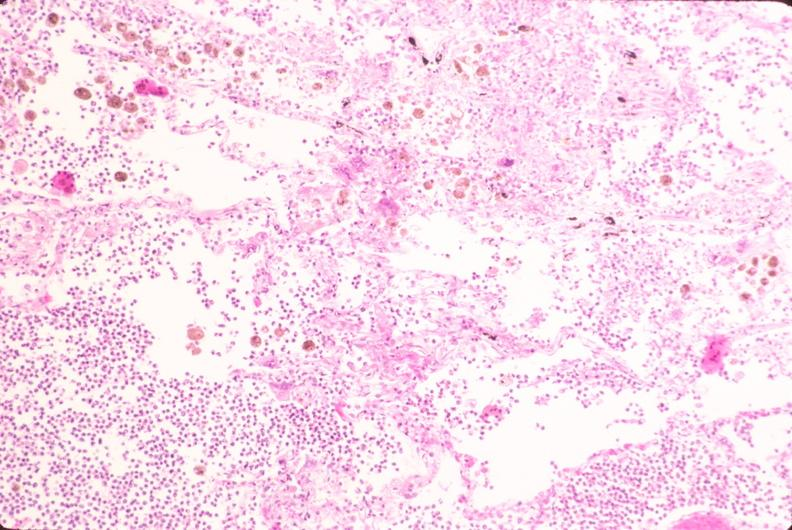s hemisection of nose present?
Answer the question using a single word or phrase. No 